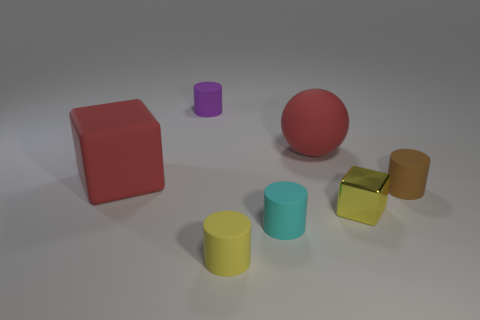What number of objects are either things that are left of the tiny metallic cube or matte things in front of the big cube?
Make the answer very short. 6. Do the block that is to the left of the cyan cylinder and the sphere have the same material?
Keep it short and to the point. Yes. The small object that is both to the left of the cyan cylinder and in front of the tiny yellow metal object is made of what material?
Keep it short and to the point. Rubber. There is a block behind the tiny brown matte object that is right of the small cyan matte cylinder; what is its color?
Your answer should be very brief. Red. What is the material of the small brown thing that is the same shape as the small yellow matte object?
Provide a succinct answer. Rubber. The cube that is in front of the rubber object that is to the left of the tiny cylinder behind the brown cylinder is what color?
Offer a terse response. Yellow. What number of objects are red blocks or tiny brown cylinders?
Your answer should be compact. 2. How many red rubber objects are the same shape as the small yellow shiny object?
Your answer should be very brief. 1. Do the big ball and the cyan cylinder that is right of the small yellow cylinder have the same material?
Offer a very short reply. Yes. There is a purple thing that is the same material as the red sphere; what is its size?
Offer a very short reply. Small. 